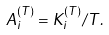Convert formula to latex. <formula><loc_0><loc_0><loc_500><loc_500>A _ { i } ^ { ( T ) } = K _ { i } ^ { ( T ) } / T .</formula> 